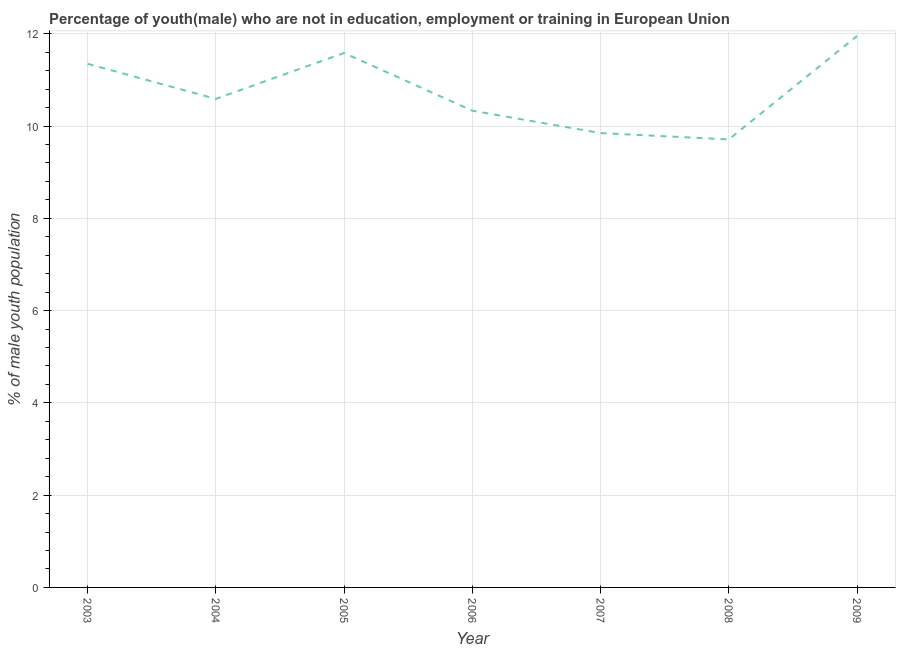What is the unemployed male youth population in 2004?
Your answer should be very brief. 10.59. Across all years, what is the maximum unemployed male youth population?
Offer a very short reply. 11.95. Across all years, what is the minimum unemployed male youth population?
Give a very brief answer. 9.71. What is the sum of the unemployed male youth population?
Provide a short and direct response. 75.37. What is the difference between the unemployed male youth population in 2003 and 2005?
Offer a very short reply. -0.24. What is the average unemployed male youth population per year?
Offer a very short reply. 10.77. What is the median unemployed male youth population?
Your answer should be very brief. 10.59. Do a majority of the years between 2006 and 2008 (inclusive) have unemployed male youth population greater than 2.4 %?
Provide a short and direct response. Yes. What is the ratio of the unemployed male youth population in 2004 to that in 2005?
Provide a succinct answer. 0.91. What is the difference between the highest and the second highest unemployed male youth population?
Provide a short and direct response. 0.37. Is the sum of the unemployed male youth population in 2005 and 2006 greater than the maximum unemployed male youth population across all years?
Make the answer very short. Yes. What is the difference between the highest and the lowest unemployed male youth population?
Offer a terse response. 2.24. In how many years, is the unemployed male youth population greater than the average unemployed male youth population taken over all years?
Keep it short and to the point. 3. Does the unemployed male youth population monotonically increase over the years?
Provide a short and direct response. No. How many years are there in the graph?
Your answer should be very brief. 7. What is the difference between two consecutive major ticks on the Y-axis?
Give a very brief answer. 2. Does the graph contain any zero values?
Make the answer very short. No. What is the title of the graph?
Your response must be concise. Percentage of youth(male) who are not in education, employment or training in European Union. What is the label or title of the X-axis?
Provide a short and direct response. Year. What is the label or title of the Y-axis?
Keep it short and to the point. % of male youth population. What is the % of male youth population of 2003?
Provide a succinct answer. 11.35. What is the % of male youth population in 2004?
Offer a terse response. 10.59. What is the % of male youth population in 2005?
Ensure brevity in your answer.  11.58. What is the % of male youth population in 2006?
Provide a short and direct response. 10.33. What is the % of male youth population in 2007?
Keep it short and to the point. 9.85. What is the % of male youth population in 2008?
Make the answer very short. 9.71. What is the % of male youth population of 2009?
Make the answer very short. 11.95. What is the difference between the % of male youth population in 2003 and 2004?
Provide a short and direct response. 0.76. What is the difference between the % of male youth population in 2003 and 2005?
Your answer should be very brief. -0.24. What is the difference between the % of male youth population in 2003 and 2006?
Keep it short and to the point. 1.02. What is the difference between the % of male youth population in 2003 and 2007?
Provide a succinct answer. 1.5. What is the difference between the % of male youth population in 2003 and 2008?
Give a very brief answer. 1.64. What is the difference between the % of male youth population in 2003 and 2009?
Your response must be concise. -0.6. What is the difference between the % of male youth population in 2004 and 2005?
Provide a short and direct response. -1. What is the difference between the % of male youth population in 2004 and 2006?
Provide a short and direct response. 0.26. What is the difference between the % of male youth population in 2004 and 2007?
Give a very brief answer. 0.74. What is the difference between the % of male youth population in 2004 and 2008?
Your response must be concise. 0.88. What is the difference between the % of male youth population in 2004 and 2009?
Provide a short and direct response. -1.36. What is the difference between the % of male youth population in 2005 and 2006?
Provide a succinct answer. 1.25. What is the difference between the % of male youth population in 2005 and 2007?
Ensure brevity in your answer.  1.74. What is the difference between the % of male youth population in 2005 and 2008?
Your answer should be very brief. 1.87. What is the difference between the % of male youth population in 2005 and 2009?
Your answer should be very brief. -0.37. What is the difference between the % of male youth population in 2006 and 2007?
Your answer should be compact. 0.48. What is the difference between the % of male youth population in 2006 and 2008?
Your answer should be compact. 0.62. What is the difference between the % of male youth population in 2006 and 2009?
Offer a very short reply. -1.62. What is the difference between the % of male youth population in 2007 and 2008?
Your response must be concise. 0.14. What is the difference between the % of male youth population in 2007 and 2009?
Provide a short and direct response. -2.1. What is the difference between the % of male youth population in 2008 and 2009?
Your answer should be very brief. -2.24. What is the ratio of the % of male youth population in 2003 to that in 2004?
Provide a succinct answer. 1.07. What is the ratio of the % of male youth population in 2003 to that in 2006?
Your answer should be compact. 1.1. What is the ratio of the % of male youth population in 2003 to that in 2007?
Offer a very short reply. 1.15. What is the ratio of the % of male youth population in 2003 to that in 2008?
Your answer should be compact. 1.17. What is the ratio of the % of male youth population in 2004 to that in 2005?
Give a very brief answer. 0.91. What is the ratio of the % of male youth population in 2004 to that in 2006?
Your answer should be compact. 1.02. What is the ratio of the % of male youth population in 2004 to that in 2007?
Provide a short and direct response. 1.07. What is the ratio of the % of male youth population in 2004 to that in 2008?
Make the answer very short. 1.09. What is the ratio of the % of male youth population in 2004 to that in 2009?
Give a very brief answer. 0.89. What is the ratio of the % of male youth population in 2005 to that in 2006?
Your response must be concise. 1.12. What is the ratio of the % of male youth population in 2005 to that in 2007?
Your answer should be very brief. 1.18. What is the ratio of the % of male youth population in 2005 to that in 2008?
Ensure brevity in your answer.  1.19. What is the ratio of the % of male youth population in 2005 to that in 2009?
Your answer should be very brief. 0.97. What is the ratio of the % of male youth population in 2006 to that in 2007?
Make the answer very short. 1.05. What is the ratio of the % of male youth population in 2006 to that in 2008?
Ensure brevity in your answer.  1.06. What is the ratio of the % of male youth population in 2006 to that in 2009?
Offer a terse response. 0.86. What is the ratio of the % of male youth population in 2007 to that in 2009?
Your answer should be compact. 0.82. What is the ratio of the % of male youth population in 2008 to that in 2009?
Give a very brief answer. 0.81. 